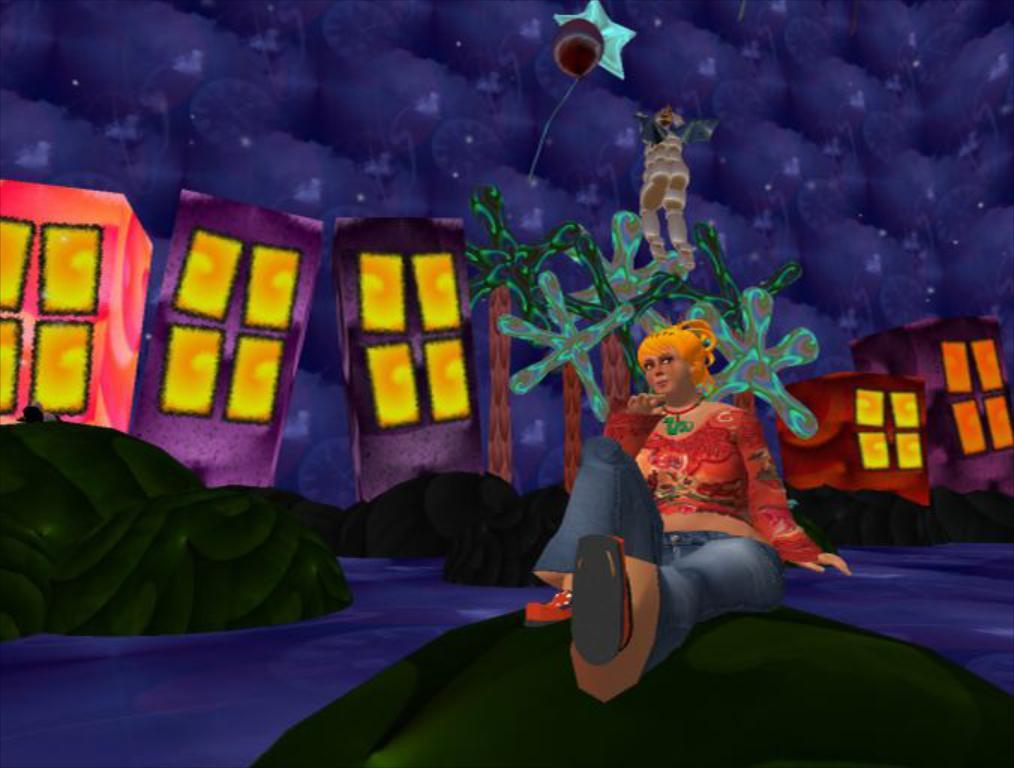What is the main subject of the image? There is a depiction of a person in the image. What else can be seen in the image besides the person? There are buildings, rocks, and a river at the bottom of the image. What type of mark can be seen on the flag in the image? There is no flag present in the image, so it is not possible to determine if there is a mark on it. 